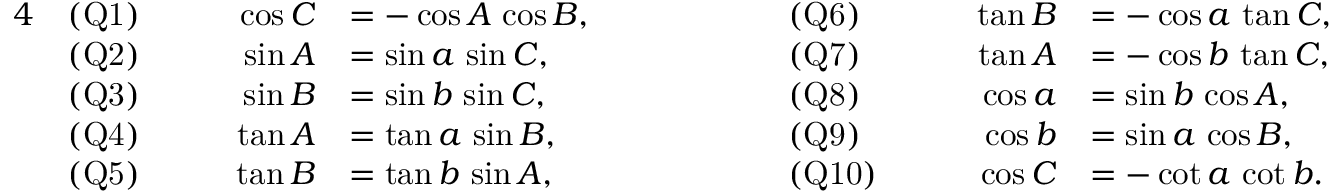Convert formula to latex. <formula><loc_0><loc_0><loc_500><loc_500>{ \begin{array} { r l r l r l r l } { 4 } & { ( Q 1 ) } & { \quad \cos C } & { = - \cos A \, \cos B , } & { \quad } & { ( Q 6 ) } & { \quad \tan B } & { = - \cos a \, \tan C , } \\ & { ( Q 2 ) } & { \sin A } & { = \sin a \, \sin C , } & & { ( Q 7 ) } & { \tan A } & { = - \cos b \, \tan C , } \\ & { ( Q 3 ) } & { \sin B } & { = \sin b \, \sin C , } & & { ( Q 8 ) } & { \cos a } & { = \sin b \, \cos A , } \\ & { ( Q 4 ) } & { \tan A } & { = \tan a \, \sin B , } & & { ( Q 9 ) } & { \cos b } & { = \sin a \, \cos B , } \\ & { ( Q 5 ) } & { \tan B } & { = \tan b \, \sin A , } & & { ( Q 1 0 ) } & { \cos C } & { = - \cot a \, \cot b . } \end{array} }</formula> 